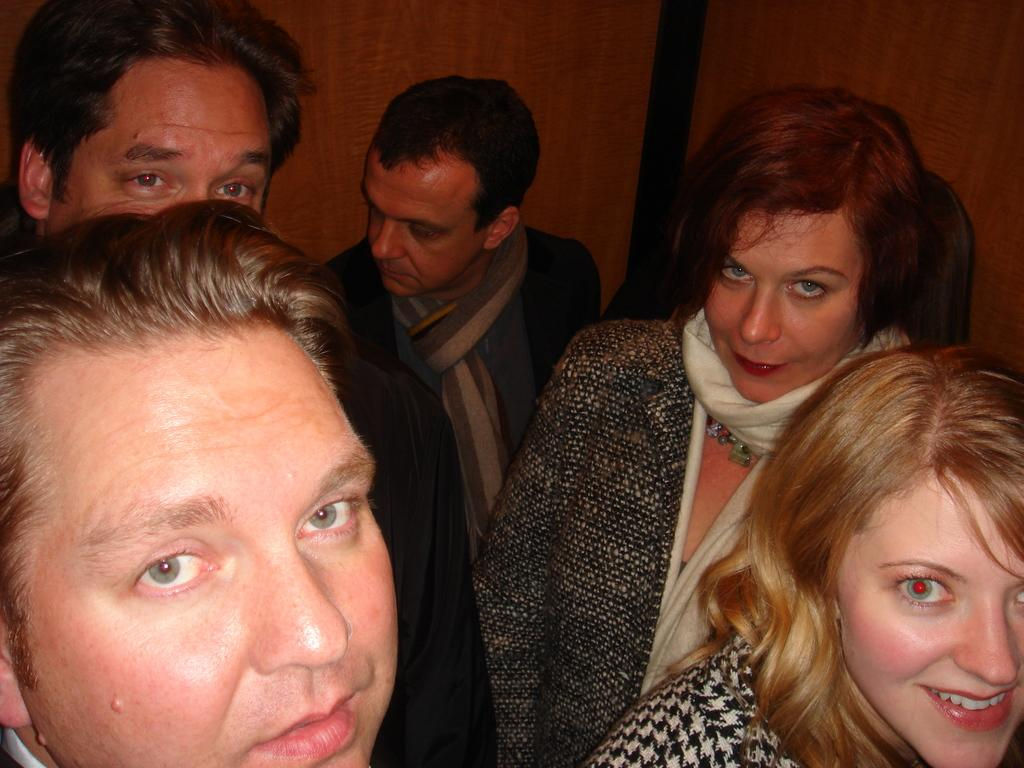What can be seen in the image? There are people standing in the image. What is visible in the background of the image? There is a wall in the background of the image. What type of coal is being used by the train in the image? There is no train present in the image, so it is not possible to determine what type of coal might be used. 